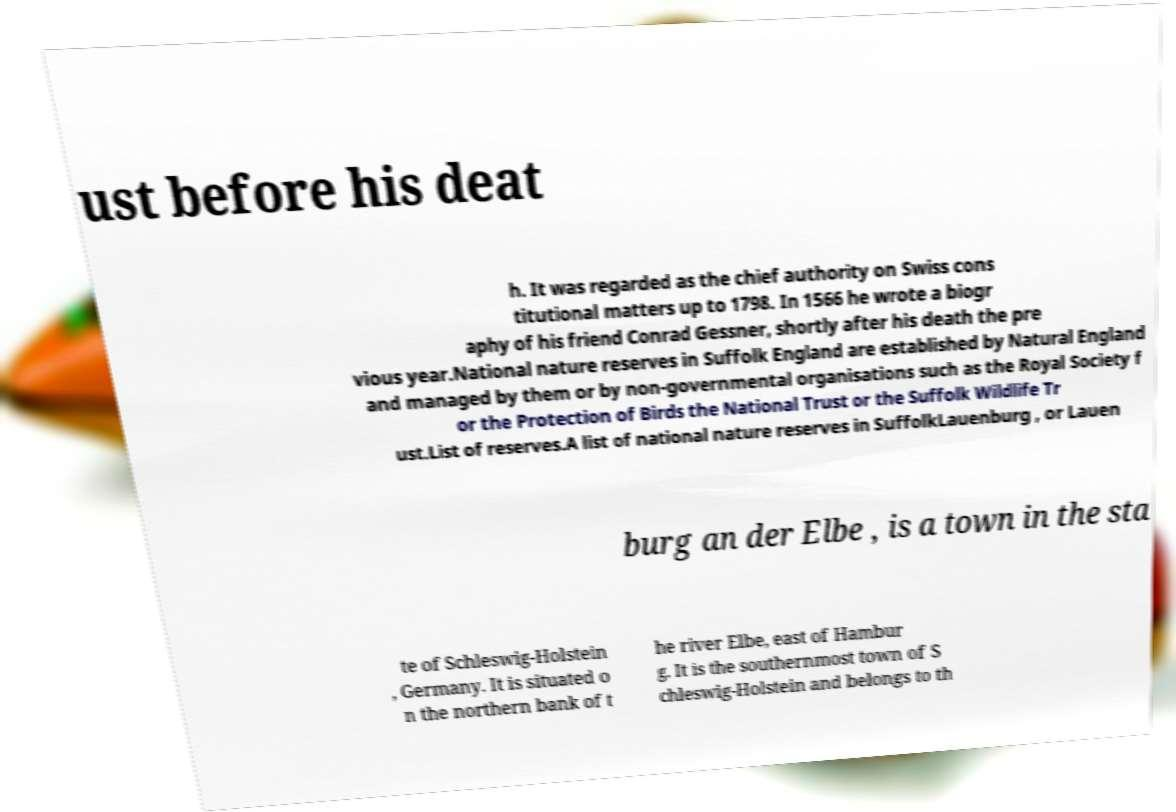Could you extract and type out the text from this image? ust before his deat h. It was regarded as the chief authority on Swiss cons titutional matters up to 1798. In 1566 he wrote a biogr aphy of his friend Conrad Gessner, shortly after his death the pre vious year.National nature reserves in Suffolk England are established by Natural England and managed by them or by non-governmental organisations such as the Royal Society f or the Protection of Birds the National Trust or the Suffolk Wildlife Tr ust.List of reserves.A list of national nature reserves in SuffolkLauenburg , or Lauen burg an der Elbe , is a town in the sta te of Schleswig-Holstein , Germany. It is situated o n the northern bank of t he river Elbe, east of Hambur g. It is the southernmost town of S chleswig-Holstein and belongs to th 